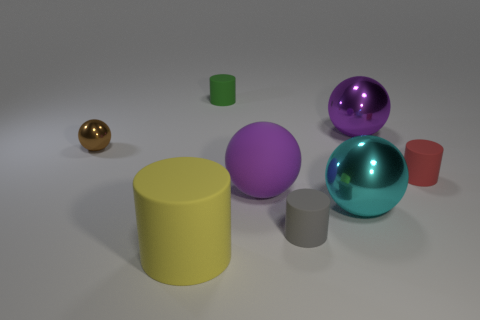There is a matte thing that is right of the large cyan object; does it have the same size as the cylinder behind the tiny brown ball?
Give a very brief answer. Yes. Is there a ball of the same size as the brown shiny thing?
Your answer should be compact. No. There is a large matte object that is behind the big rubber cylinder; does it have the same shape as the brown thing?
Give a very brief answer. Yes. There is a big purple sphere that is on the left side of the tiny gray thing; what is it made of?
Your response must be concise. Rubber. What shape is the purple thing in front of the thing that is left of the big yellow rubber thing?
Provide a short and direct response. Sphere. Is the shape of the large purple matte thing the same as the small object that is to the left of the yellow matte thing?
Provide a short and direct response. Yes. What number of big matte cylinders are left of the purple sphere that is in front of the tiny brown thing?
Make the answer very short. 1. There is a tiny brown object that is the same shape as the cyan metallic thing; what is it made of?
Offer a very short reply. Metal. What number of green things are either small matte objects or big rubber balls?
Give a very brief answer. 1. Is there anything else that is the same color as the small sphere?
Your response must be concise. No. 